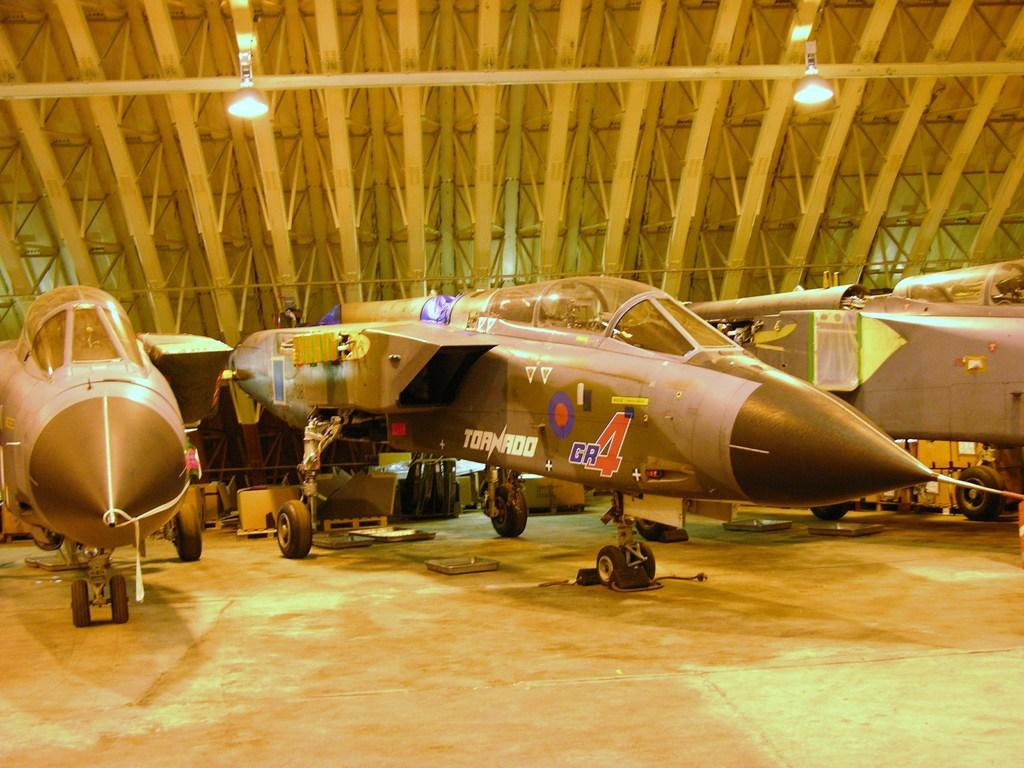Provide a one-sentence caption for the provided image. A military fighter plane is labeled on its side with the word Tornado. 